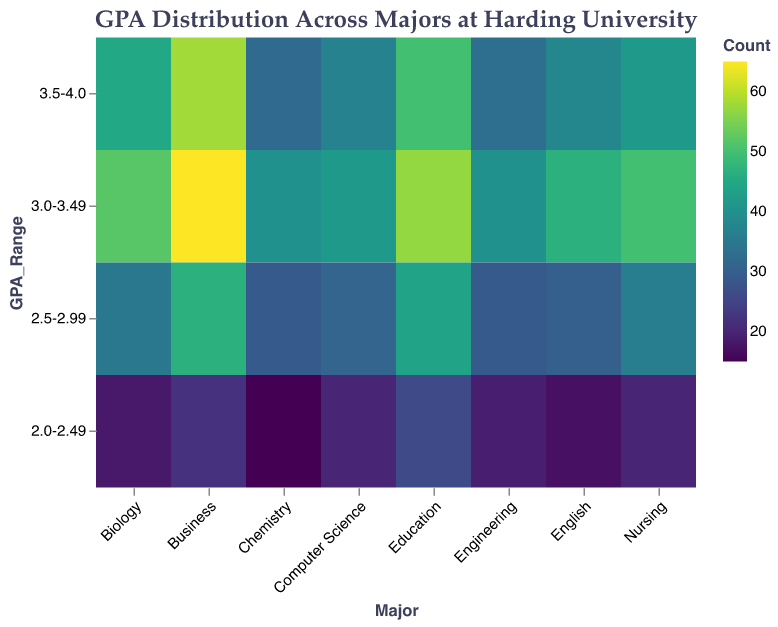What's the title of the heatmap? The title of the heatmap is displayed at the top and it clearly states the focus of the data being represented.
Answer: GPA Distribution Across Majors at Harding University Which major has the highest count of students with a GPA in the range 3.5-4.0? By looking at the vertical axis at the "3.5-4.0" GPA range and comparing the counts across the different majors, it shows the highest count color for Business.
Answer: Business How many students have a GPA of 3.0-3.49 in the Computer Science major? The count for the GPA range "3.0-3.49" under the Computer Science major can be identified in the cell corresponding to this intersection, which shows the value.
Answer: 42 Which GPA range has the lowest number of students in Chemistry? By examining the four cells corresponding to Chemistry across different GPA ranges, the one with the lightest color indicates the lowest count.
Answer: 2.0-2.49 What is the total count of students majoring in Biology across all GPA ranges? Sum the counts for each GPA range within the Biology major: 45 (3.5-4.0) + 52 (3.0-3.49) + 35 (2.5-2.99) + 18 (2.0-2.49). This equals 150.
Answer: 150 Compare the number of students in the highest GPA range (3.5-4.0) between Nursing and Engineering. Which has more? Compare the counts in the cell representing the intersection of Nursing with "3.5-4.0" and Engineering with "3.5-4.0". Nursing has more students (42 vs. 33).
Answer: Nursing Which major has the most evenly distributed GPA counts across all ranges? Evaluate the visual density (color uniformity) across all GPA ranges for each major. The one with the fewest extreme colors (dark or light) is Education.
Answer: Education How does the number of students in the highest GPA range (3.5-4.0) for Business compare to English? The cell representing Business with GPA “3.5-4.0” shows a count of 58 and English shows a count of 38. Therefore, Business has more students.
Answer: Business What's the combined number of students in the GPA ranges 2.5-2.99 and 2.0-2.49 in Engineering? Add the counts in the cells representing Engineering with GPA ranges of 2.5-2.99 (29) and 2.0-2.49 (19). This equals 48.
Answer: 48 Which major has the least number of students with a GPA between 2.0-2.49? Compare the counts for the GPA range "2.0-2.49" across all majors. The cell with the lowest value indicates the least number of students. Chemistry has 15 students.
Answer: Chemistry 